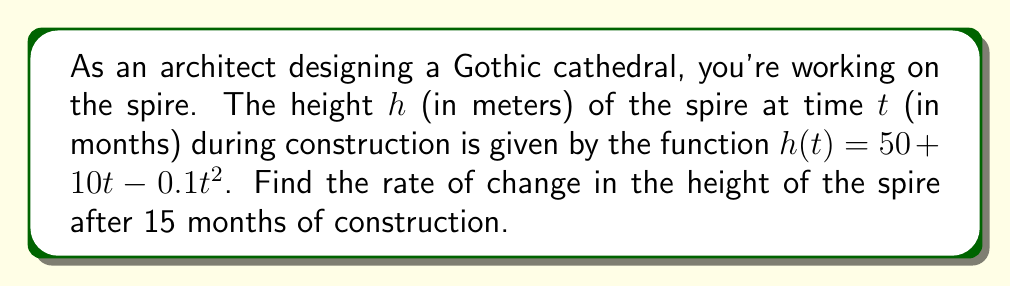What is the answer to this math problem? To find the rate of change in the height of the spire, we need to calculate the derivative of the height function $h(t)$ and evaluate it at $t = 15$ months.

Step 1: Identify the height function
$$h(t) = 50 + 10t - 0.1t^2$$

Step 2: Calculate the derivative $h'(t)$
Using the power rule and constant rule:
$$h'(t) = 0 + 10 - 0.2t$$

Step 3: Simplify the derivative
$$h'(t) = 10 - 0.2t$$

Step 4: Evaluate $h'(t)$ at $t = 15$
$$h'(15) = 10 - 0.2(15) = 10 - 3 = 7$$

The rate of change is measured in meters per month, as height is in meters and time is in months.
Answer: $7$ m/month 